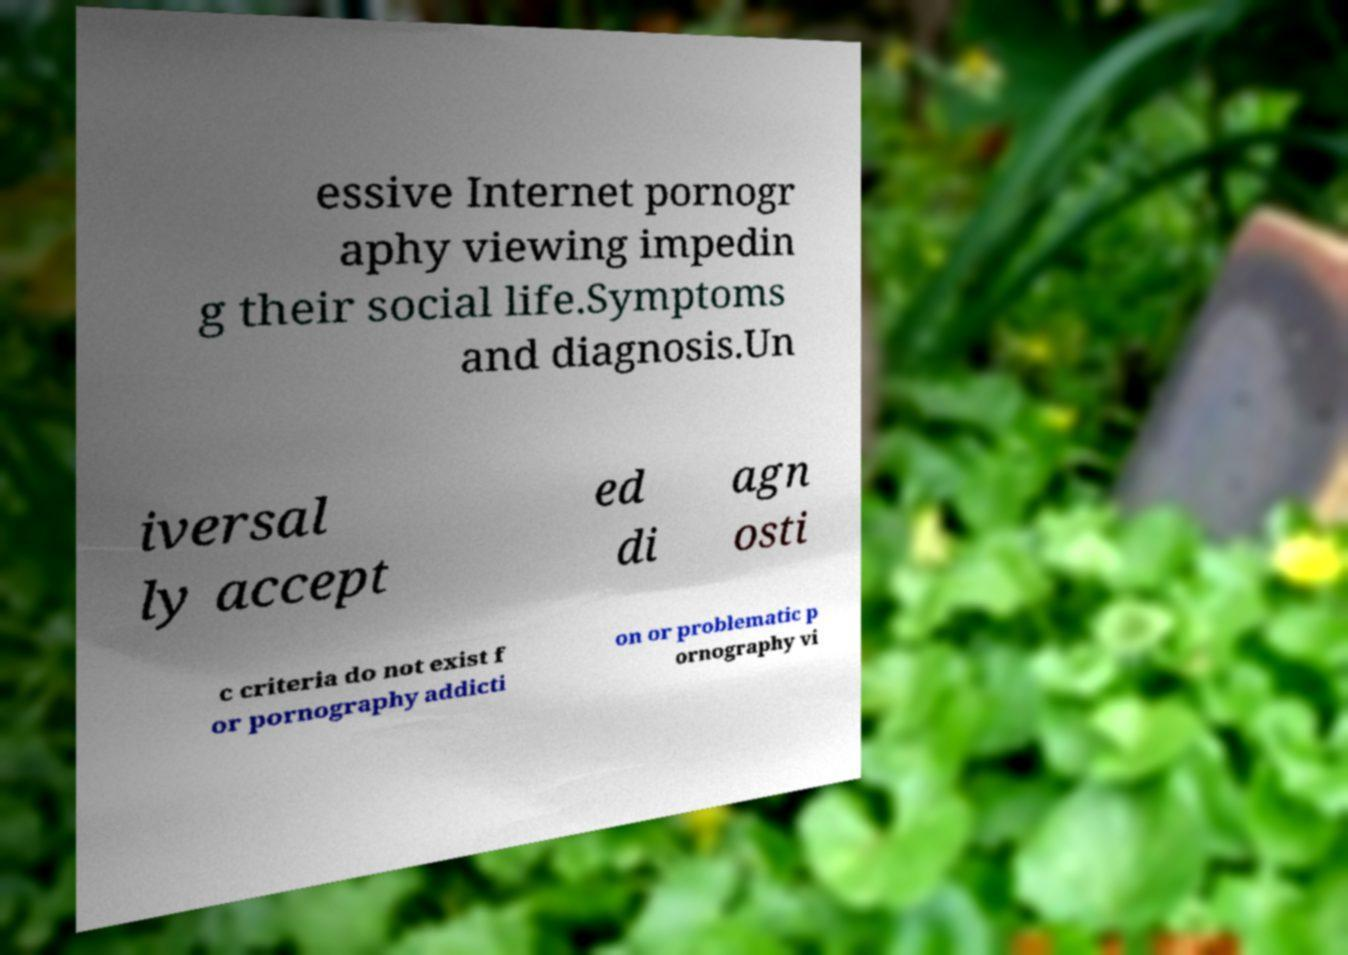For documentation purposes, I need the text within this image transcribed. Could you provide that? essive Internet pornogr aphy viewing impedin g their social life.Symptoms and diagnosis.Un iversal ly accept ed di agn osti c criteria do not exist f or pornography addicti on or problematic p ornography vi 